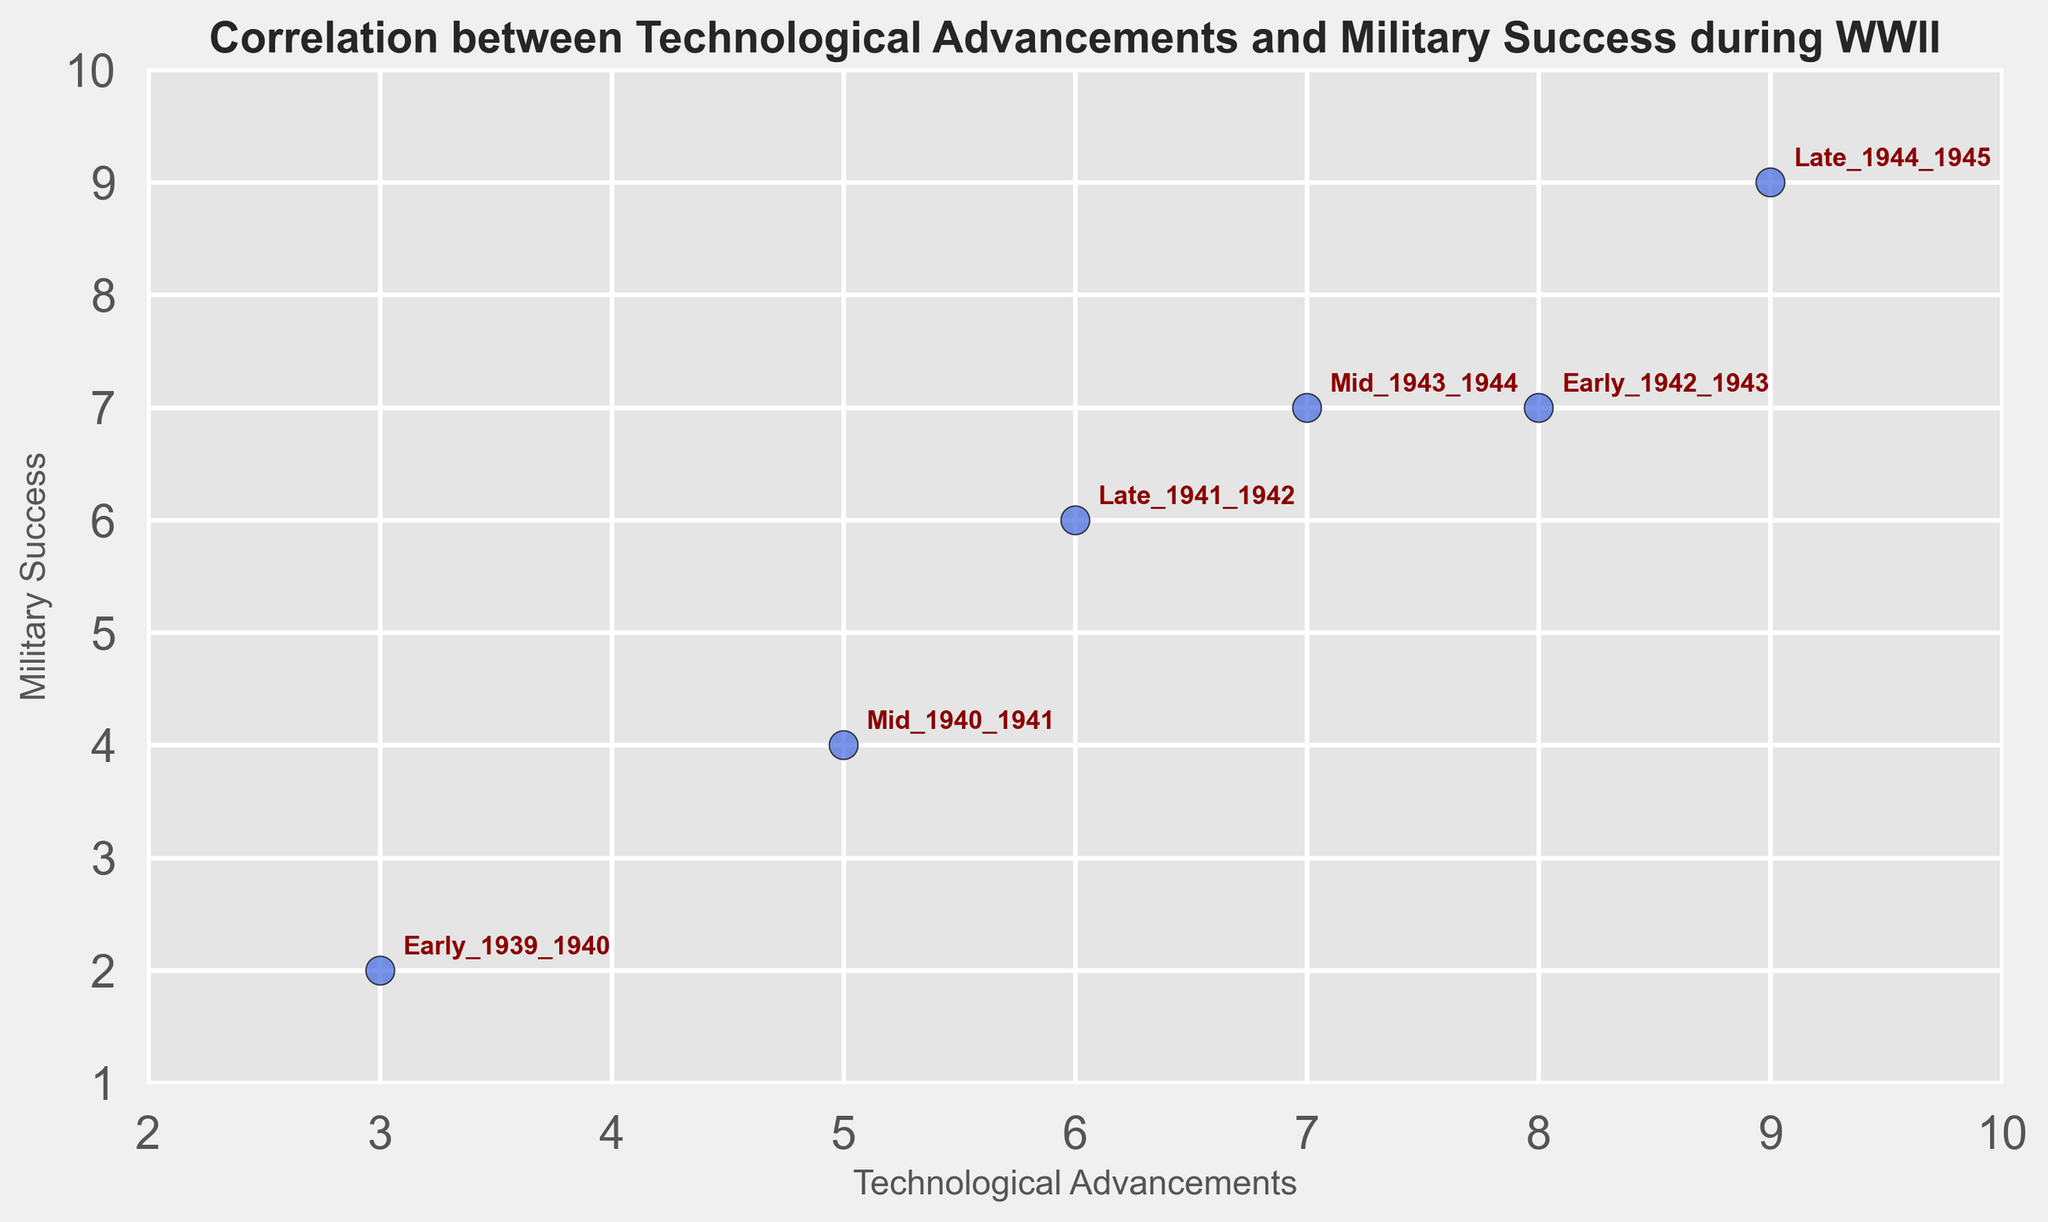What does the scatter plot show about the relationship between technological advancements and military success during WWII? The scatter plot shows a positive correlation between technological advancements and military success over different phases of WWII. As the level of technological advancements increases, military success also tends to increase.
Answer: Positive correlation Which phase had the highest level of technological advancements and military success? By looking at the scatter plot, the Late_1944_1945 phase had the highest values for both technological advancements and military success.
Answer: Late_1944_1945 What is the phase with the largest increase in military success compared to the previous phase? To determine this, look at the differences in military success between phases. From Early_1939_1940 to Mid_1940_1941, there's an increase of 2 units in military success which is the largest compared to other phases.
Answer: Mid_1940_1941 On average, how do technological advancements and military success change from early to late phases of WWII? Calculate the average technological advancements and military success for Early phases (1939-1943) and Late phases (1944-1945). For early phases: (3+5+6+8)/4 = 5.5 for technologies and (2+4+6+7)/4 = 4.75 for success. For late phases: (7+9)/2 = 8 for technologies and (7+9)/2 = 8 for success. Hence, both metrics show an increase from early to late phases.
Answer: Increase What phase shows an equal level of technological advancements and military success? By examining the data points, the phases where technological advancements and military success are equal are Mid_1943_1944 (both are 7).
Answer: Mid_1943_1944 Which phase shows the smallest increase in technological advancements compared to the previous phase? Compare technological advancements between consecutive phases. The Mid_1943_1944 phase shows a decrease from the Early_1942_1943 (7 from 8), which is the only phase with no increase.
Answer: Mid_1943_1944 Identify the phase with the second-highest military success. By examining the scatter plot, the second-highest military success value is 7, which belongs to both Early_1942_1943 and Mid_1943_1944 phases.
Answer: Early_1942_1943 or Mid_1943_1944 What is the visual trend in the scatter plot from Early_1939_1940 to Late_1944_1945? The scatter plot shows an upward trend where both technological advancements and military success increase from Early_1939_1940 to Late_1944_1945.
Answer: Upward trend What is the difference in technological advancements between Early_1939_1940 and Early_1942_1943? Compare technological advancements for the two phases: 8 (Early_1942_1943) - 3 (Early_1939_1940) = 5.
Answer: 5 